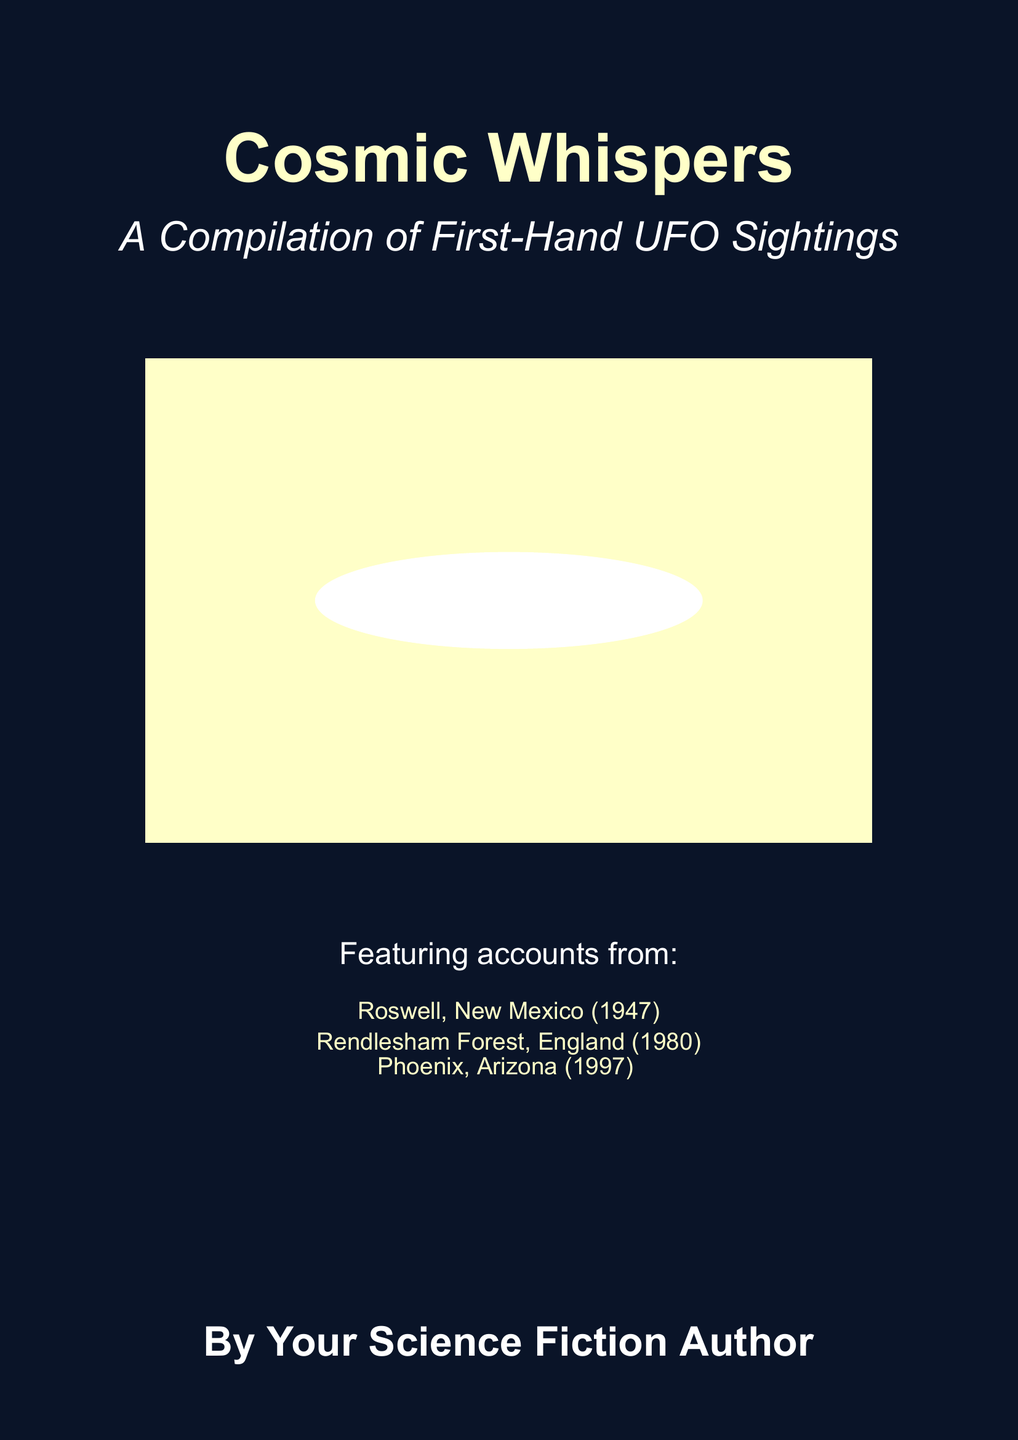What is the title of the book? The title of the book is the main heading displayed prominently.
Answer: Cosmic Whispers What is the subtitle of the book? The subtitle is an explanation of the main title and is usually in smaller font.
Answer: A Compilation of First-Hand UFO Sightings How many UFO sighting accounts are mentioned? Three locations of UFO sightings are listed in the text under "Featuring accounts from".
Answer: Three Which state is associated with the 1947 sighting? The location of the 1947 sighting is specified in the list of accounts.
Answer: New Mexico What color is used for the background? The background color is described in the document, which gives a sense of the atmosphere.
Answer: Night sky What kind of illustrations are used for the book cover? The visual elements are making up the look of the book cover, including notable features and style.
Answer: Shooting stars and a silhouette of a mysterious flying object What font style is used for the main text? The font style used for the text can indicate the book’s theme and feel.
Answer: Arial What effect is used to depict stars in the background? The effect refers to how the stars are visually represented in the book cover design.
Answer: Glow What is the author's designation on the cover? This indicates the authorship claim presented on the cover.
Answer: By Your Science Fiction Author 